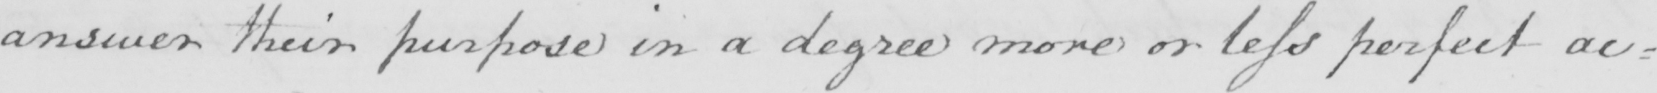Transcribe the text shown in this historical manuscript line. answer their purpose in a degree more or less perfect ac= 